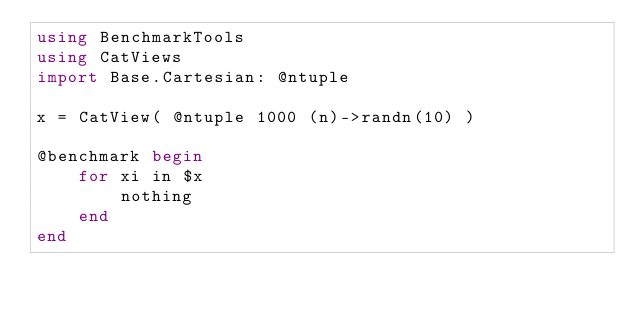<code> <loc_0><loc_0><loc_500><loc_500><_Julia_>using BenchmarkTools
using CatViews
import Base.Cartesian: @ntuple

x = CatView( @ntuple 1000 (n)->randn(10) )

@benchmark begin
    for xi in $x
        nothing
    end
end
</code> 